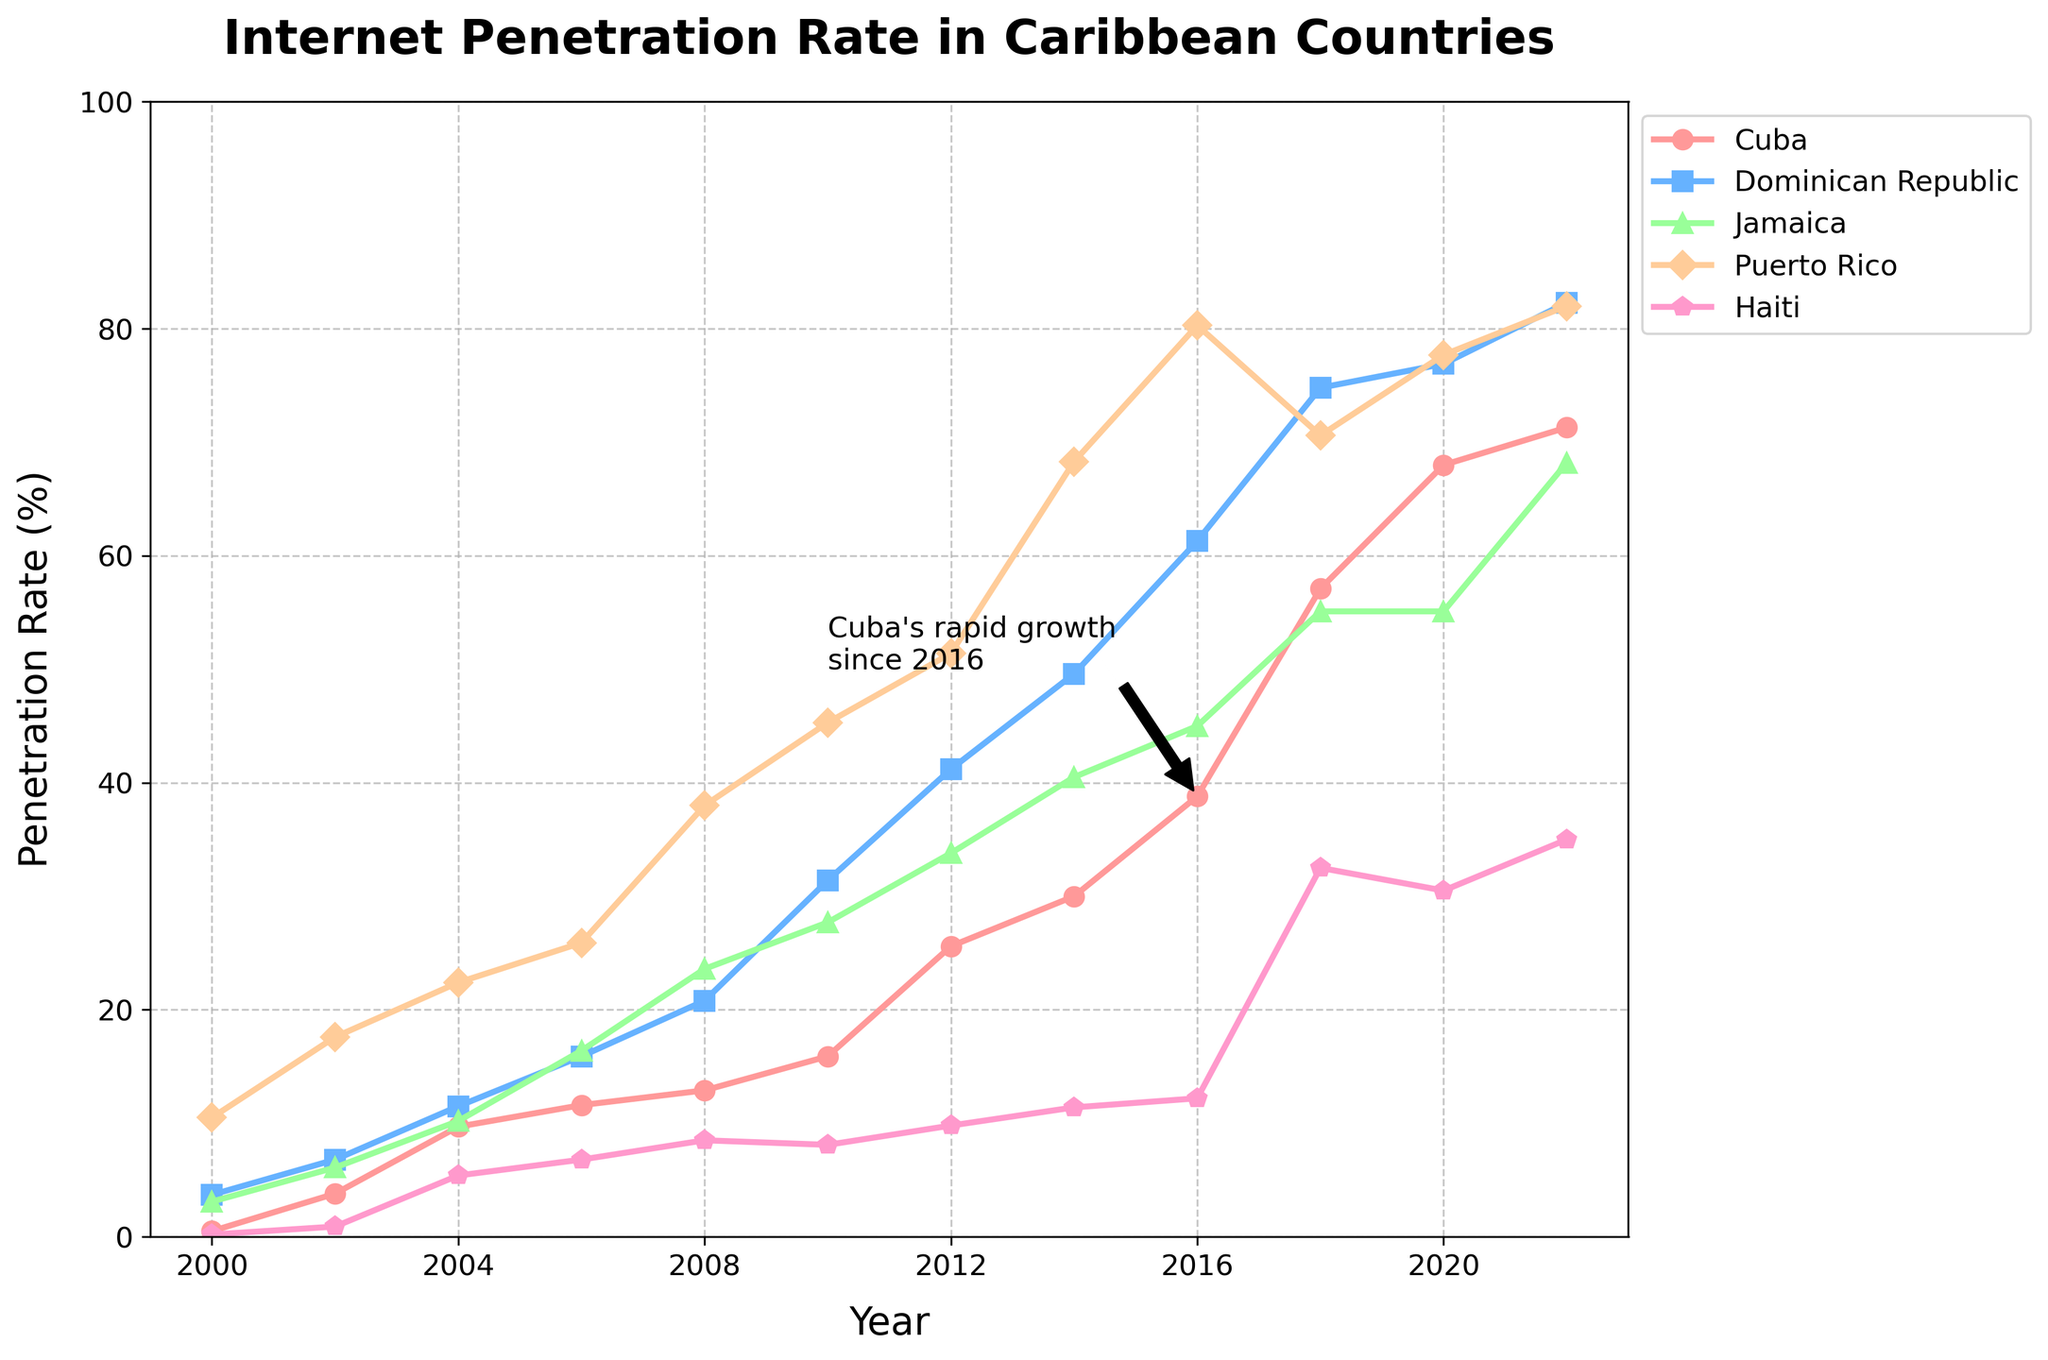Which country had the highest internet penetration rate by 2022? By looking at the endpoint of the 2022 lines on the y-axis, Puerto Rico has the highest penetration rate, reaching around 82%.
Answer: Puerto Rico By how much did Cuba's internet penetration rate increase from 2014 to 2022? In 2014, Cuba's rate was 30.0%, and by 2022 it was 71.3%. The increase can be calculated as 71.3% - 30.0% = 41.3%.
Answer: 41.3% Which two countries had almost the same internet penetration rate in 2018? By checking the values in 2018, Dominican Republic and Puerto Rico had very close rates: 74.8% and 70.6%, respectively.
Answer: Dominican Republic and Puerto Rico During which period did Haiti see a significant increase in internet penetration? Observing Haiti's line, there is a noticeable increase between 2016 (12.2%) and 2018 (32.5%).
Answer: 2016-2018 What is the approximate difference in internet penetration rates between Cuba and Jamaica in 2020? In 2020, Cuba's rate was 68.0%, and Jamaica's was 55.1%. The difference can be calculated as 68.0% - 55.1% = 12.9%.
Answer: 12.9% What visual feature emphasizes Cuba's rapid growth after 2016? There is an annotation pointing to the significant rise in Cuba's line starting 2016, labeled "Cuba's rapid growth since 2016."
Answer: An annotation Which country showed the steadiest growth in internet penetration from 2000 to 2022? By comparing the smoothness and steadiness of the lines, Puerto Rico consistently increases at a steady rate from 2000 to 2022.
Answer: Puerto Rico In which year did the Dominican Republic's internet penetration rate first surpass 50%? Examining the Dominican Republic's line, it surpassed the 50% mark around 2014.
Answer: 2014 